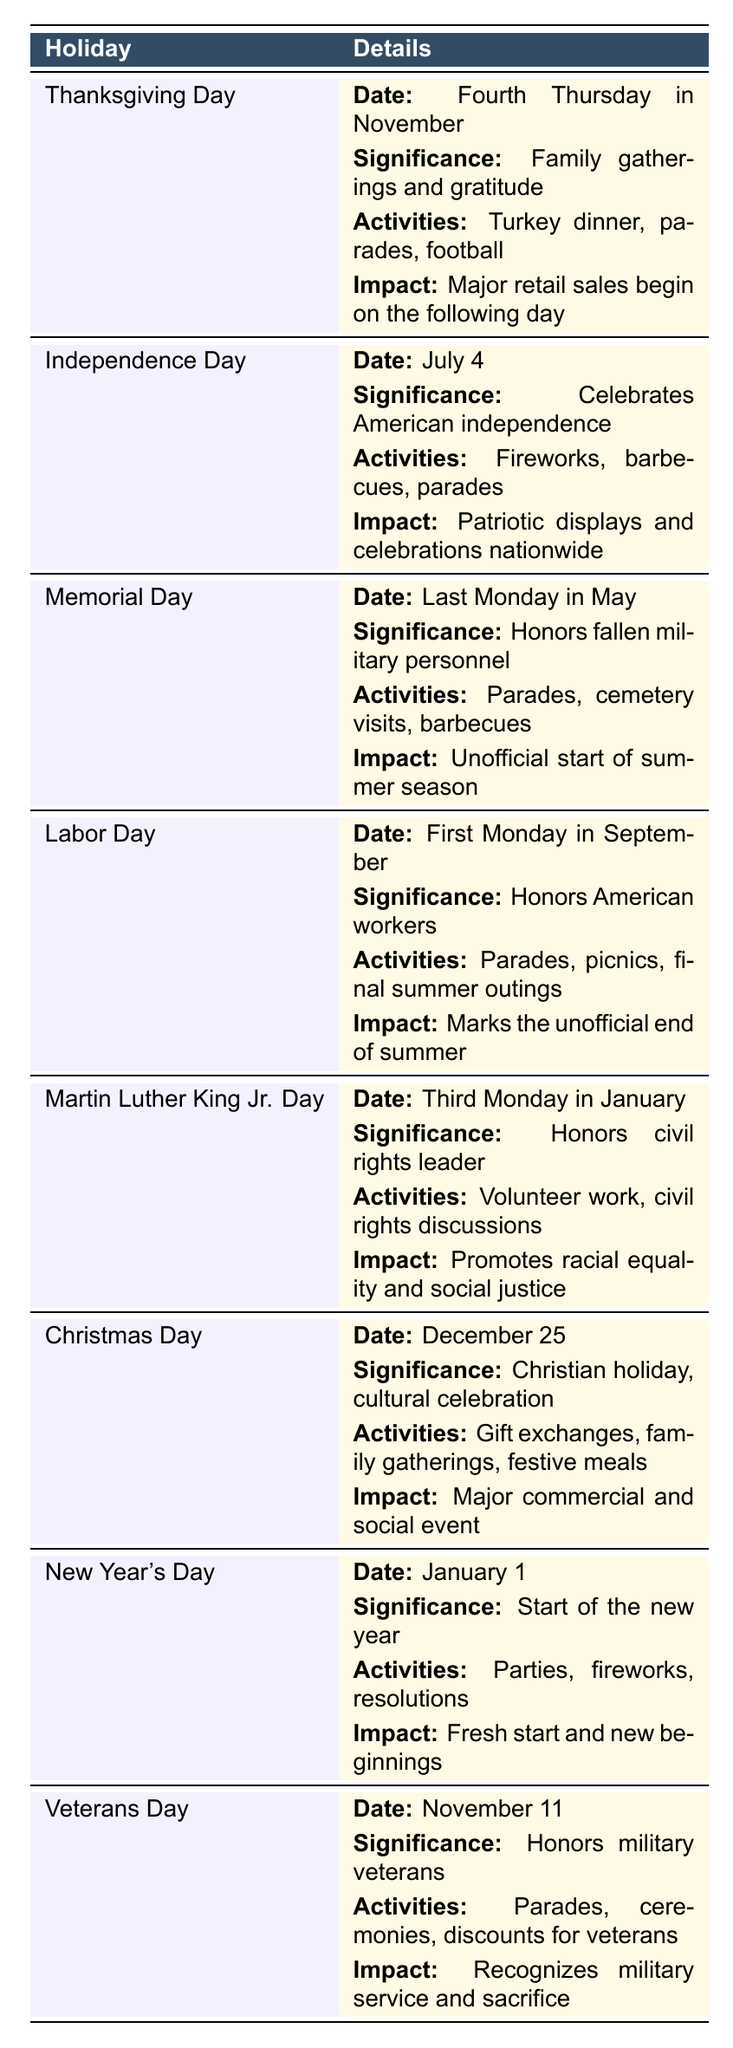What is the significance of Memorial Day? Memorial Day is described in the table as a holiday that honors fallen military personnel. This information can be directly retrieved from the "significance" column associated with Memorial Day.
Answer: Honors fallen military personnel On which date is Independence Day celebrated? The table clearly lists Independence Day with its date provided directly in the "date" column, which states it is celebrated on July 4.
Answer: July 4 Which holiday is associated with family gatherings and gratitude? By reviewing the "significance" column, we find that Thanksgiving Day is noted for family gatherings and expressing gratitude.
Answer: Thanksgiving Day How many holidays are recognized in the table? By counting the rows in the table dedicated to different holidays, we see that there are 8 entries listed in total.
Answer: 8 Is Christmas Day associated with a cultural celebration? The table indicates that Christmas Day is a Christian holiday that also serves as a cultural celebration, confirming the statement as true.
Answer: Yes Which holiday signifies the unofficial end of summer? The significance of Labor Day is mentioned in the table as marking the unofficial end of summer, making it the answer.
Answer: Labor Day What typical activities are observed on New Year’s Day? The table states in the "typical activities" section that parties, fireworks, and resolutions are observed on New Year’s Day.
Answer: Parties, fireworks, resolutions Identify the holidays that involve parades. By scanning through the "typical activities" column, we can identify Memorial Day, Independence Day, and Labor Day as holidays that prominently feature parades.
Answer: Memorial Day, Independence Day, Labor Day Which holiday promotes racial equality and social justice? The table indicates that Martin Luther King Jr. Day is specifically recognized for promoting racial equality and social justice as part of its significance.
Answer: Martin Luther King Jr. Day What is the typical activity associated with Thanksgiving Day? Looking at the "typical activities" column, we see that Thanksgiving Day is associated with a turkey dinner, parades, and football.
Answer: Turkey dinner, parades, football 